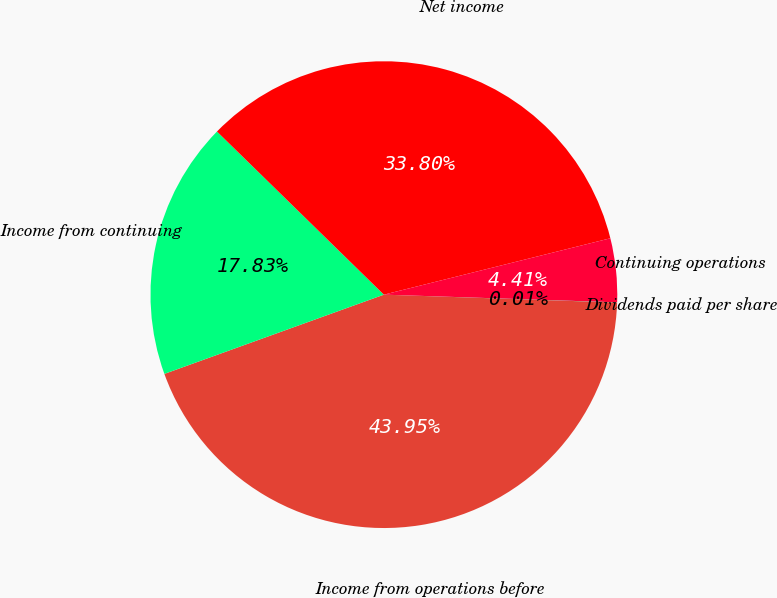Convert chart. <chart><loc_0><loc_0><loc_500><loc_500><pie_chart><fcel>Income from operations before<fcel>Income from continuing<fcel>Net income<fcel>Continuing operations<fcel>Dividends paid per share<nl><fcel>43.95%<fcel>17.83%<fcel>33.8%<fcel>4.41%<fcel>0.01%<nl></chart> 